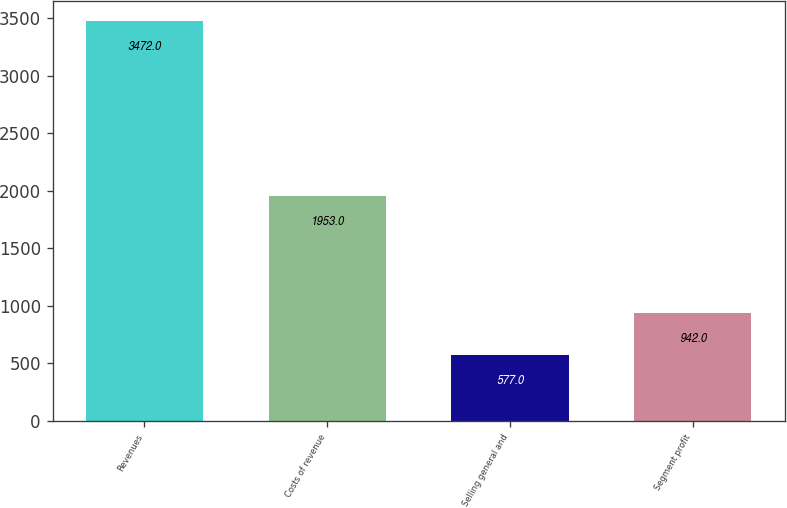<chart> <loc_0><loc_0><loc_500><loc_500><bar_chart><fcel>Revenues<fcel>Costs of revenue<fcel>Selling general and<fcel>Segment profit<nl><fcel>3472<fcel>1953<fcel>577<fcel>942<nl></chart> 